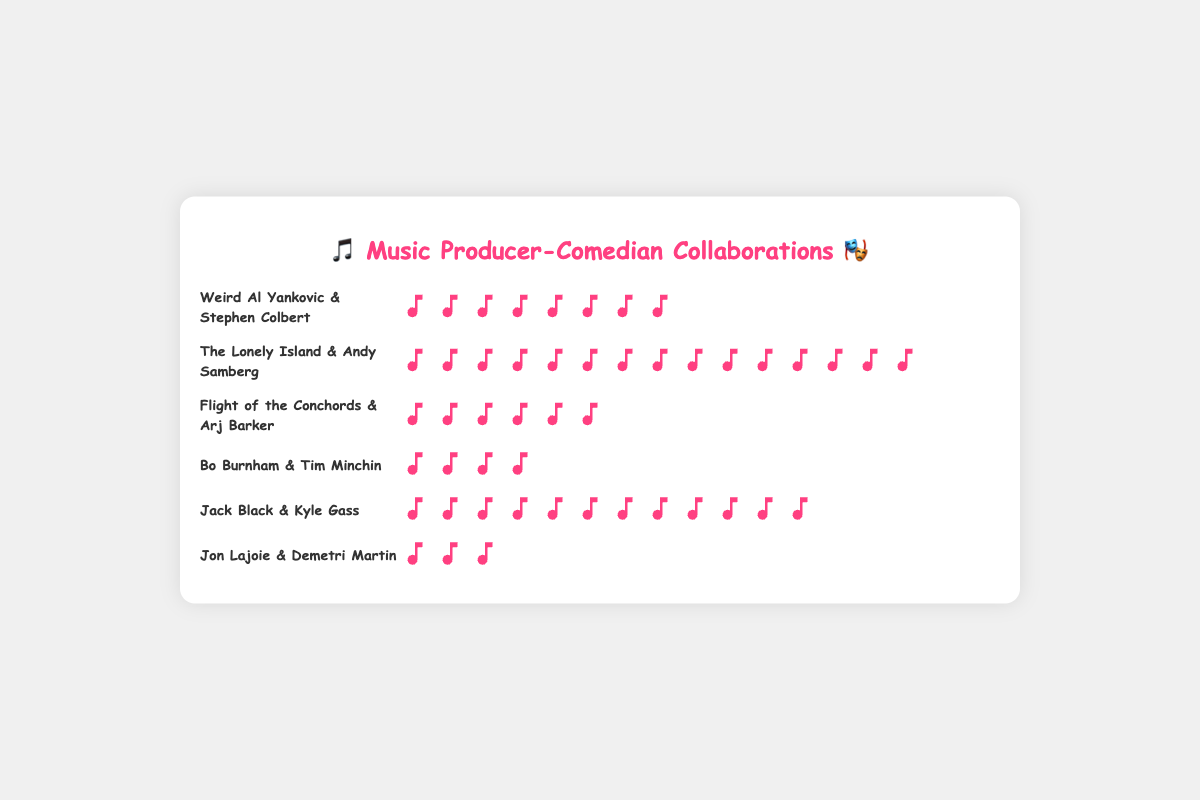who are the top three music producers with the highest frequency of collaborations? The top three can be identified by counting the icons for each collaboration. The producers with the highest frequency are The Lonely Island (15), Jack Black (12), and Weird Al Yankovic (8).
Answer: The Lonely Island, Jack Black, Weird Al Yankovic How many total collaborations did Jon Lajoie and Flight of the Conchords have together? Add the individual frequencies of Jon Lajoie (3) and Flight of the Conchords (6).
Answer: 9 Which collaboration has the fewest frequency? The collaboration with the fewest icons, representing frequency, is Jon Lajoie and Demetri Martin with 3.
Answer: Jon Lajoie & Demetri Martin How much more frequent are The Lonely Island's collaborations compared to Bo Burnham's? Subtract Bo Burnham's frequency (4) from The Lonely Island's frequency (15).
Answer: 11 What's the total number of collaborations between all given pairs? Sum all the frequencies: 8 + 15 + 6 + 4 + 12 + 3 = 48.
Answer: 48 Which collaboration comes after Jack Black and Kyle Gass in terms of frequency? Jack Black and Kyle Gass have a frequency of 12. The collaboration with the next highest frequency is Weird Al Yankovic and Stephen Colbert with 8.
Answer: Weird Al Yankovic & Stephen Colbert How many icons would you find for the collaborations involving comedians with first names starting with 'A'? Sum the frequencies where the comedian's first name starts with 'A': Andy Samberg (15) and Arj Barker (6).
Answer: 21 If you combine all the icons for Bo Burnham and Jack Black, what would be the new frequency? Sum Bo Burnham's frequency (4) and Jack Black's frequency (12).
Answer: 16 Which music producer has the second smallest number of collaborations, and what is the frequency? The second smallest frequency among producers is held by Bo Burnham with a frequency of 4; the smallest is Jon Lajoie with a frequency of 3.
Answer: Bo Burnham, 4 